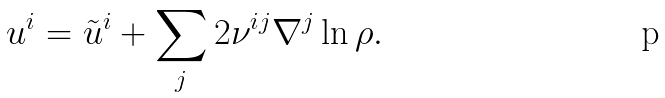<formula> <loc_0><loc_0><loc_500><loc_500>u ^ { i } = \tilde { u } ^ { i } + \sum _ { j } 2 \nu ^ { i j } \nabla ^ { j } \ln \rho .</formula> 